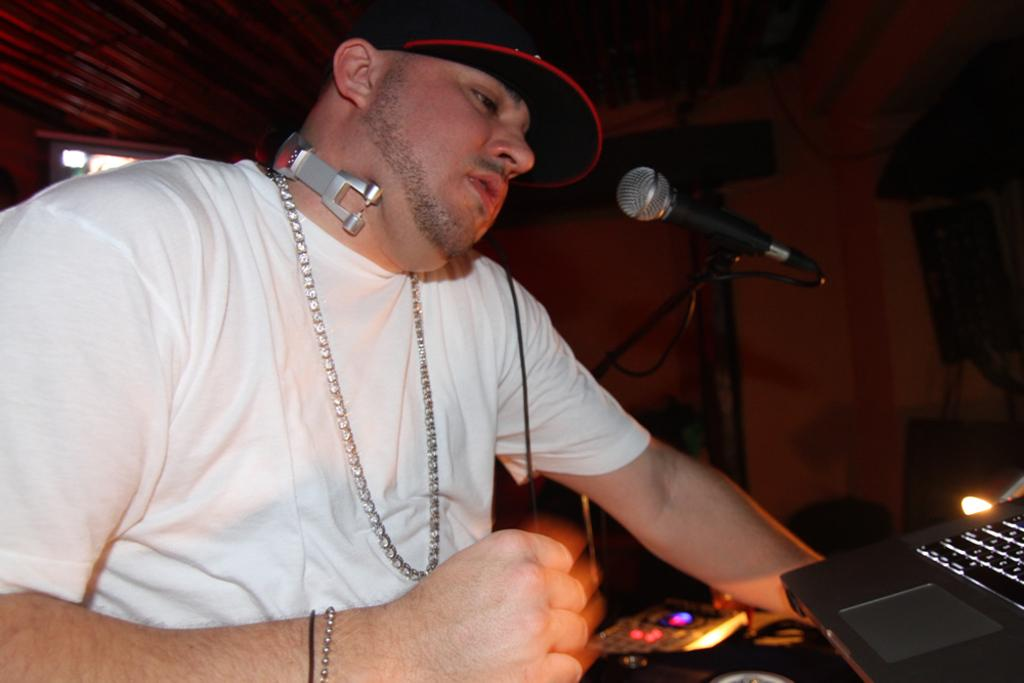Who is the main subject in the image? There is a man in the image. What is the man interacting with in the image? There is a microphone, a laptop, and a light in front of the man. What might the man be using the laptop for? The man might be using the laptop for presenting, recording, or accessing information. What is the purpose of the light in front of the man? The light could be for illuminating the man or the objects in front of him, or for creating a specific visual effect. What type of songs can be heard in the image? There is no audio present in the image, so it is not possible to determine what songs might be heard. 